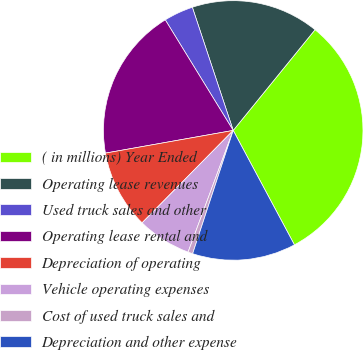<chart> <loc_0><loc_0><loc_500><loc_500><pie_chart><fcel>( in millions) Year Ended<fcel>Operating lease revenues<fcel>Used truck sales and other<fcel>Operating lease rental and<fcel>Depreciation of operating<fcel>Vehicle operating expenses<fcel>Cost of used truck sales and<fcel>Depreciation and other expense<nl><fcel>31.32%<fcel>15.96%<fcel>3.67%<fcel>19.03%<fcel>9.81%<fcel>6.74%<fcel>0.59%<fcel>12.88%<nl></chart> 